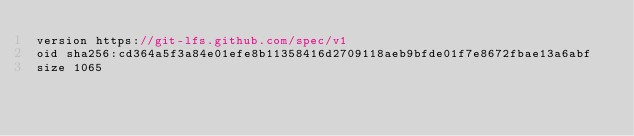Convert code to text. <code><loc_0><loc_0><loc_500><loc_500><_JavaScript_>version https://git-lfs.github.com/spec/v1
oid sha256:cd364a5f3a84e01efe8b11358416d2709118aeb9bfde01f7e8672fbae13a6abf
size 1065
</code> 